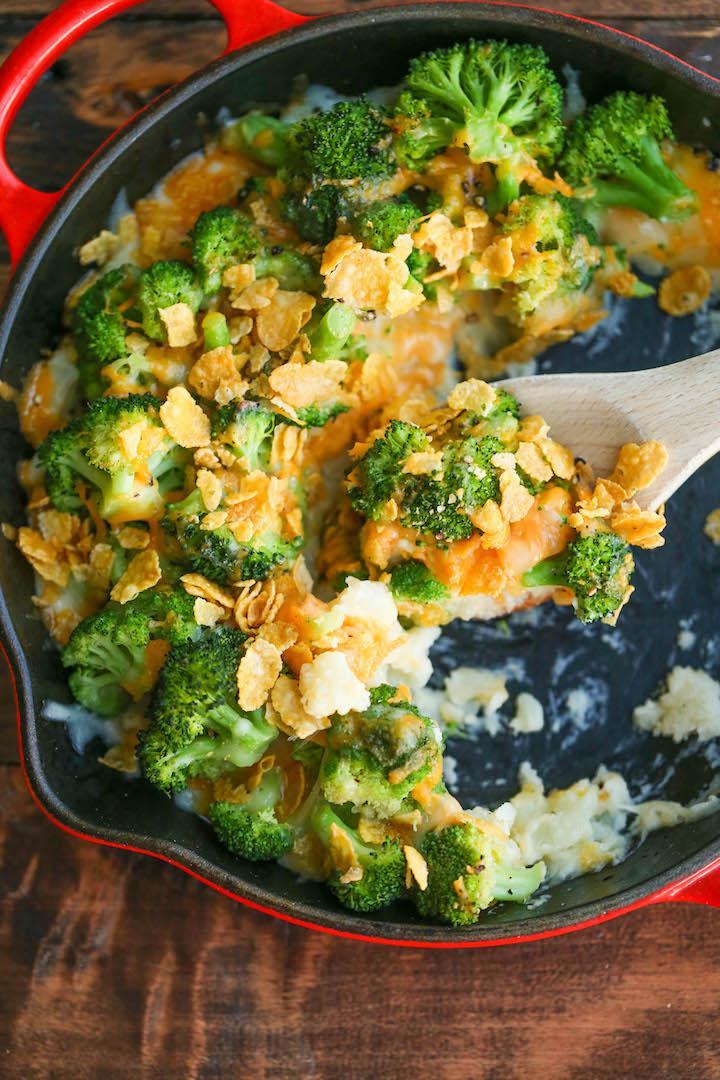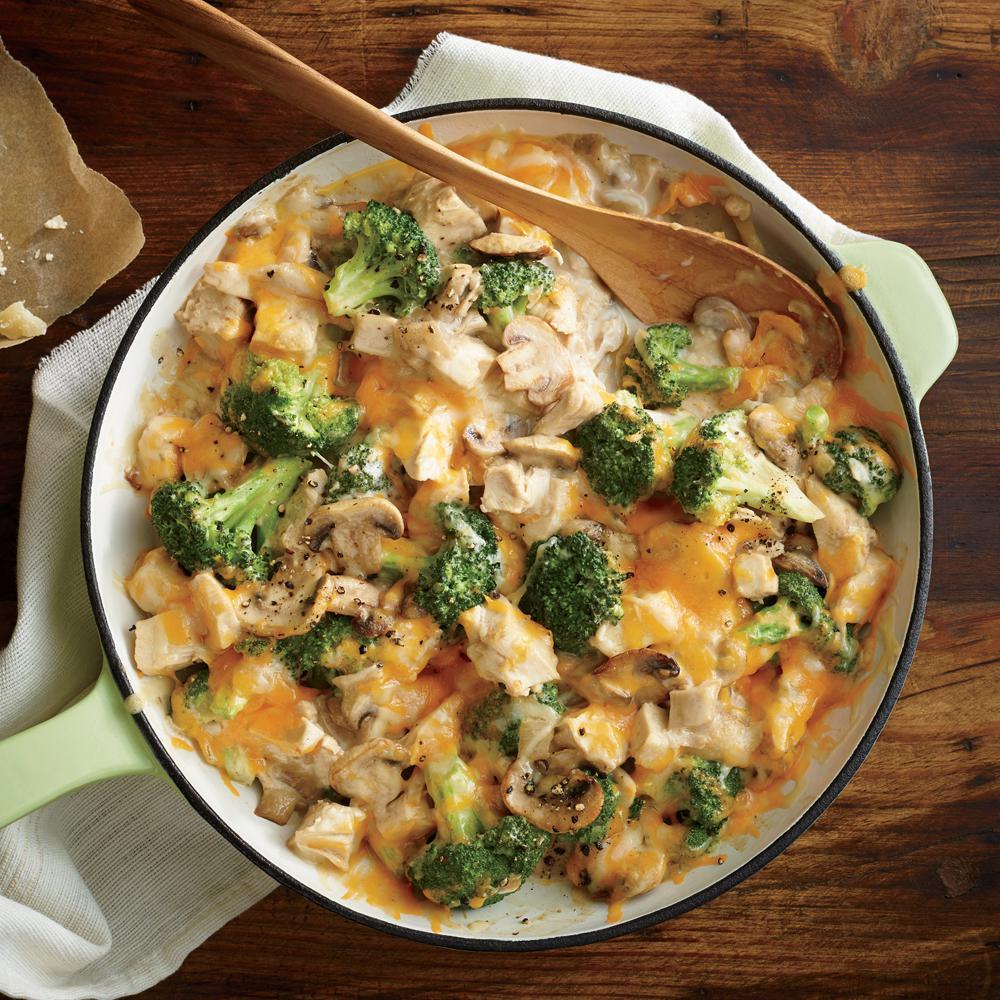The first image is the image on the left, the second image is the image on the right. For the images shown, is this caption "Both images show food served on an all-white dish." true? Answer yes or no. No. The first image is the image on the left, the second image is the image on the right. Given the left and right images, does the statement "The food is one a white plate in the image on the left." hold true? Answer yes or no. No. 